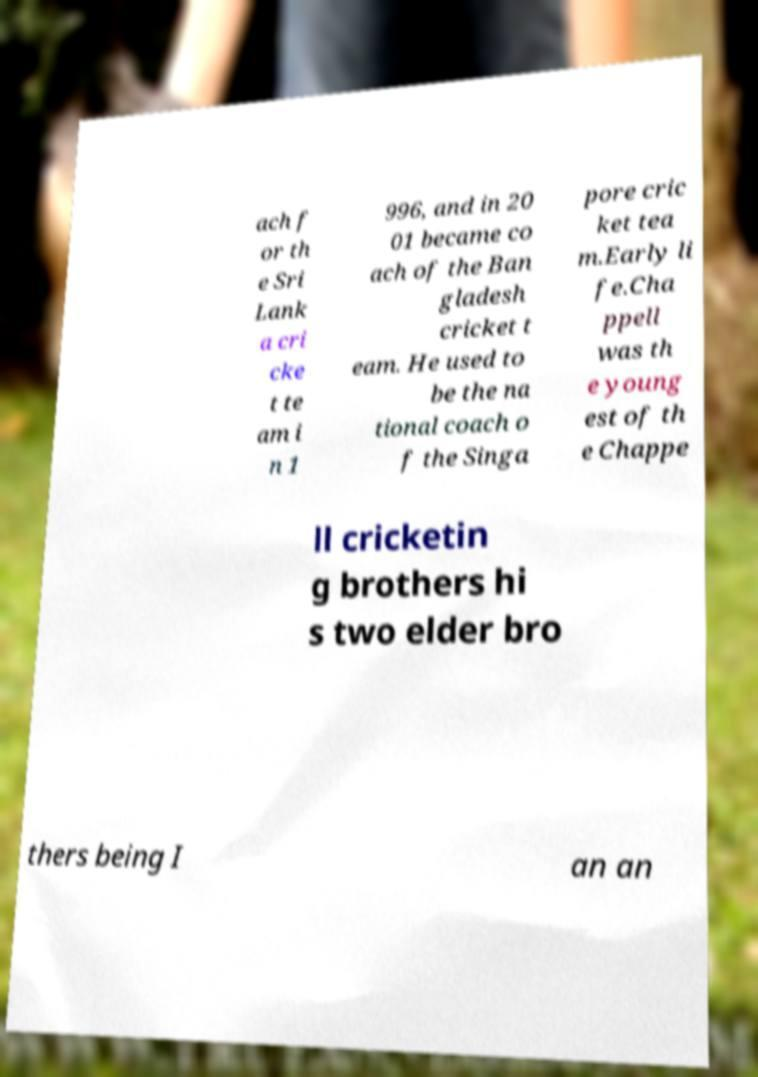Please read and relay the text visible in this image. What does it say? ach f or th e Sri Lank a cri cke t te am i n 1 996, and in 20 01 became co ach of the Ban gladesh cricket t eam. He used to be the na tional coach o f the Singa pore cric ket tea m.Early li fe.Cha ppell was th e young est of th e Chappe ll cricketin g brothers hi s two elder bro thers being I an an 